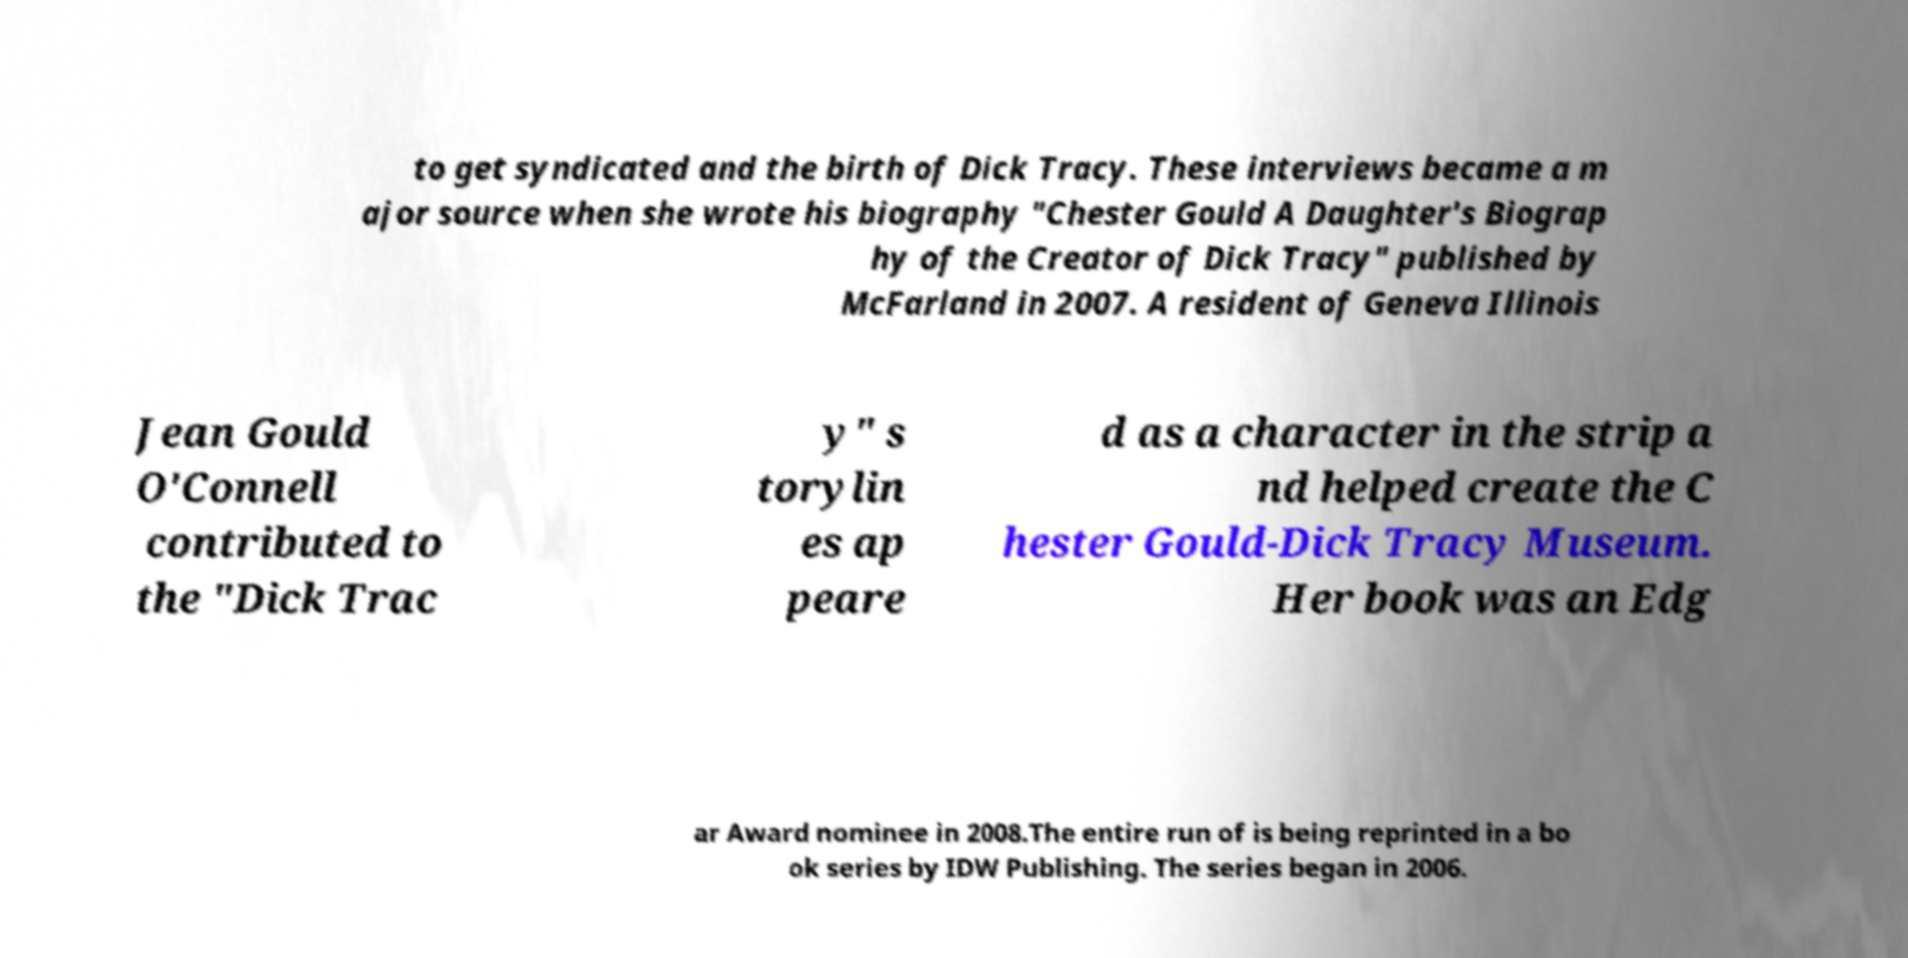Could you assist in decoding the text presented in this image and type it out clearly? to get syndicated and the birth of Dick Tracy. These interviews became a m ajor source when she wrote his biography "Chester Gould A Daughter's Biograp hy of the Creator of Dick Tracy" published by McFarland in 2007. A resident of Geneva Illinois Jean Gould O'Connell contributed to the "Dick Trac y" s torylin es ap peare d as a character in the strip a nd helped create the C hester Gould-Dick Tracy Museum. Her book was an Edg ar Award nominee in 2008.The entire run of is being reprinted in a bo ok series by IDW Publishing. The series began in 2006. 